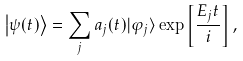Convert formula to latex. <formula><loc_0><loc_0><loc_500><loc_500>\left | \psi ( t ) \right \rangle = \sum _ { j } a _ { j } ( t ) | \varphi _ { j } \rangle \exp \left [ \frac { E _ { j } t } { i } \right ] ,</formula> 